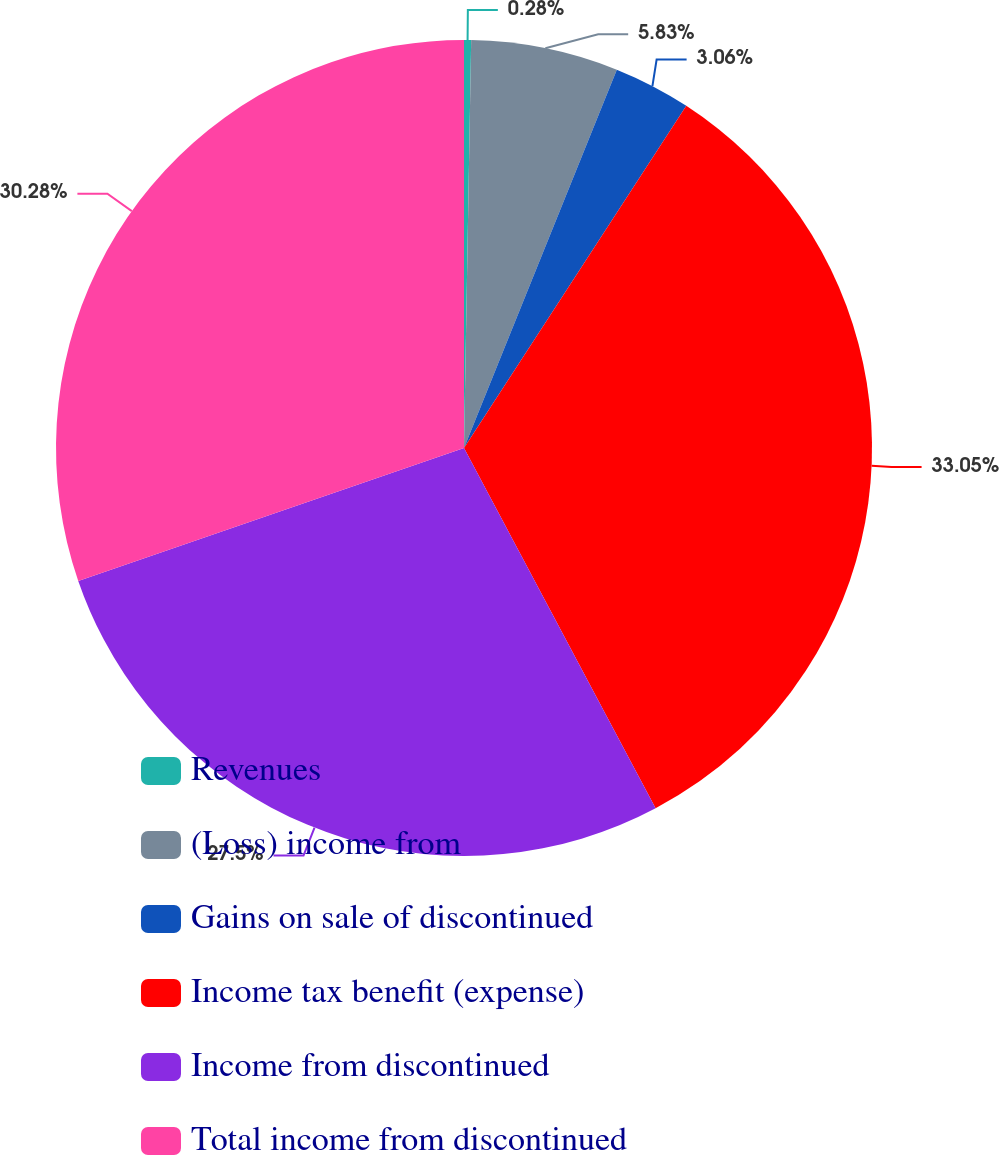Convert chart. <chart><loc_0><loc_0><loc_500><loc_500><pie_chart><fcel>Revenues<fcel>(Loss) income from<fcel>Gains on sale of discontinued<fcel>Income tax benefit (expense)<fcel>Income from discontinued<fcel>Total income from discontinued<nl><fcel>0.28%<fcel>5.83%<fcel>3.06%<fcel>33.05%<fcel>27.5%<fcel>30.28%<nl></chart> 